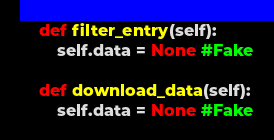<code> <loc_0><loc_0><loc_500><loc_500><_Python_>    def filter_entry(self):
        self.data = None #Fake
        
    def download_data(self):
        self.data = None #Fake</code> 